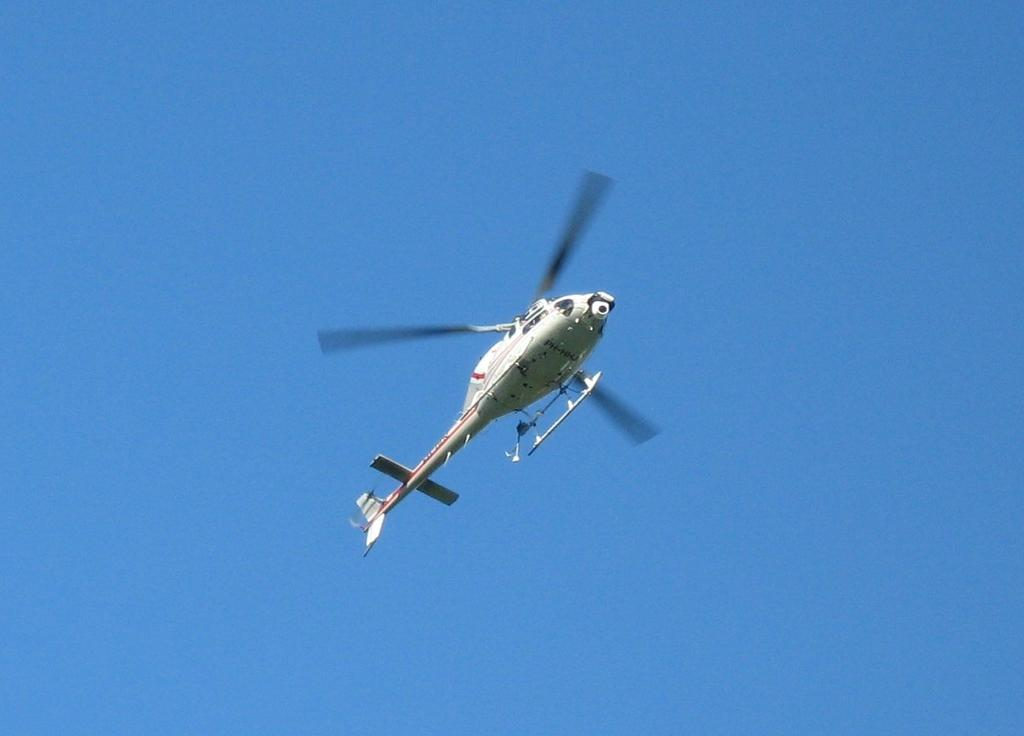What is the main subject of the image? There is an aircraft in the image. What is the color of the aircraft? The aircraft is white in color. What can be seen in the background of the image? The sky is blue in the background of the image. Are there any islands visible in the image? There are no islands present in the image; it features an aircraft and a blue sky. What type of selection process is being depicted in the image? There is no selection process depicted in the image; it features an aircraft and a blue sky. 